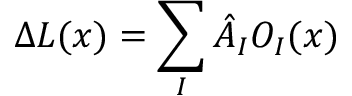Convert formula to latex. <formula><loc_0><loc_0><loc_500><loc_500>\Delta L ( x ) = \sum _ { I } \hat { A } _ { I } O _ { I } ( x )</formula> 